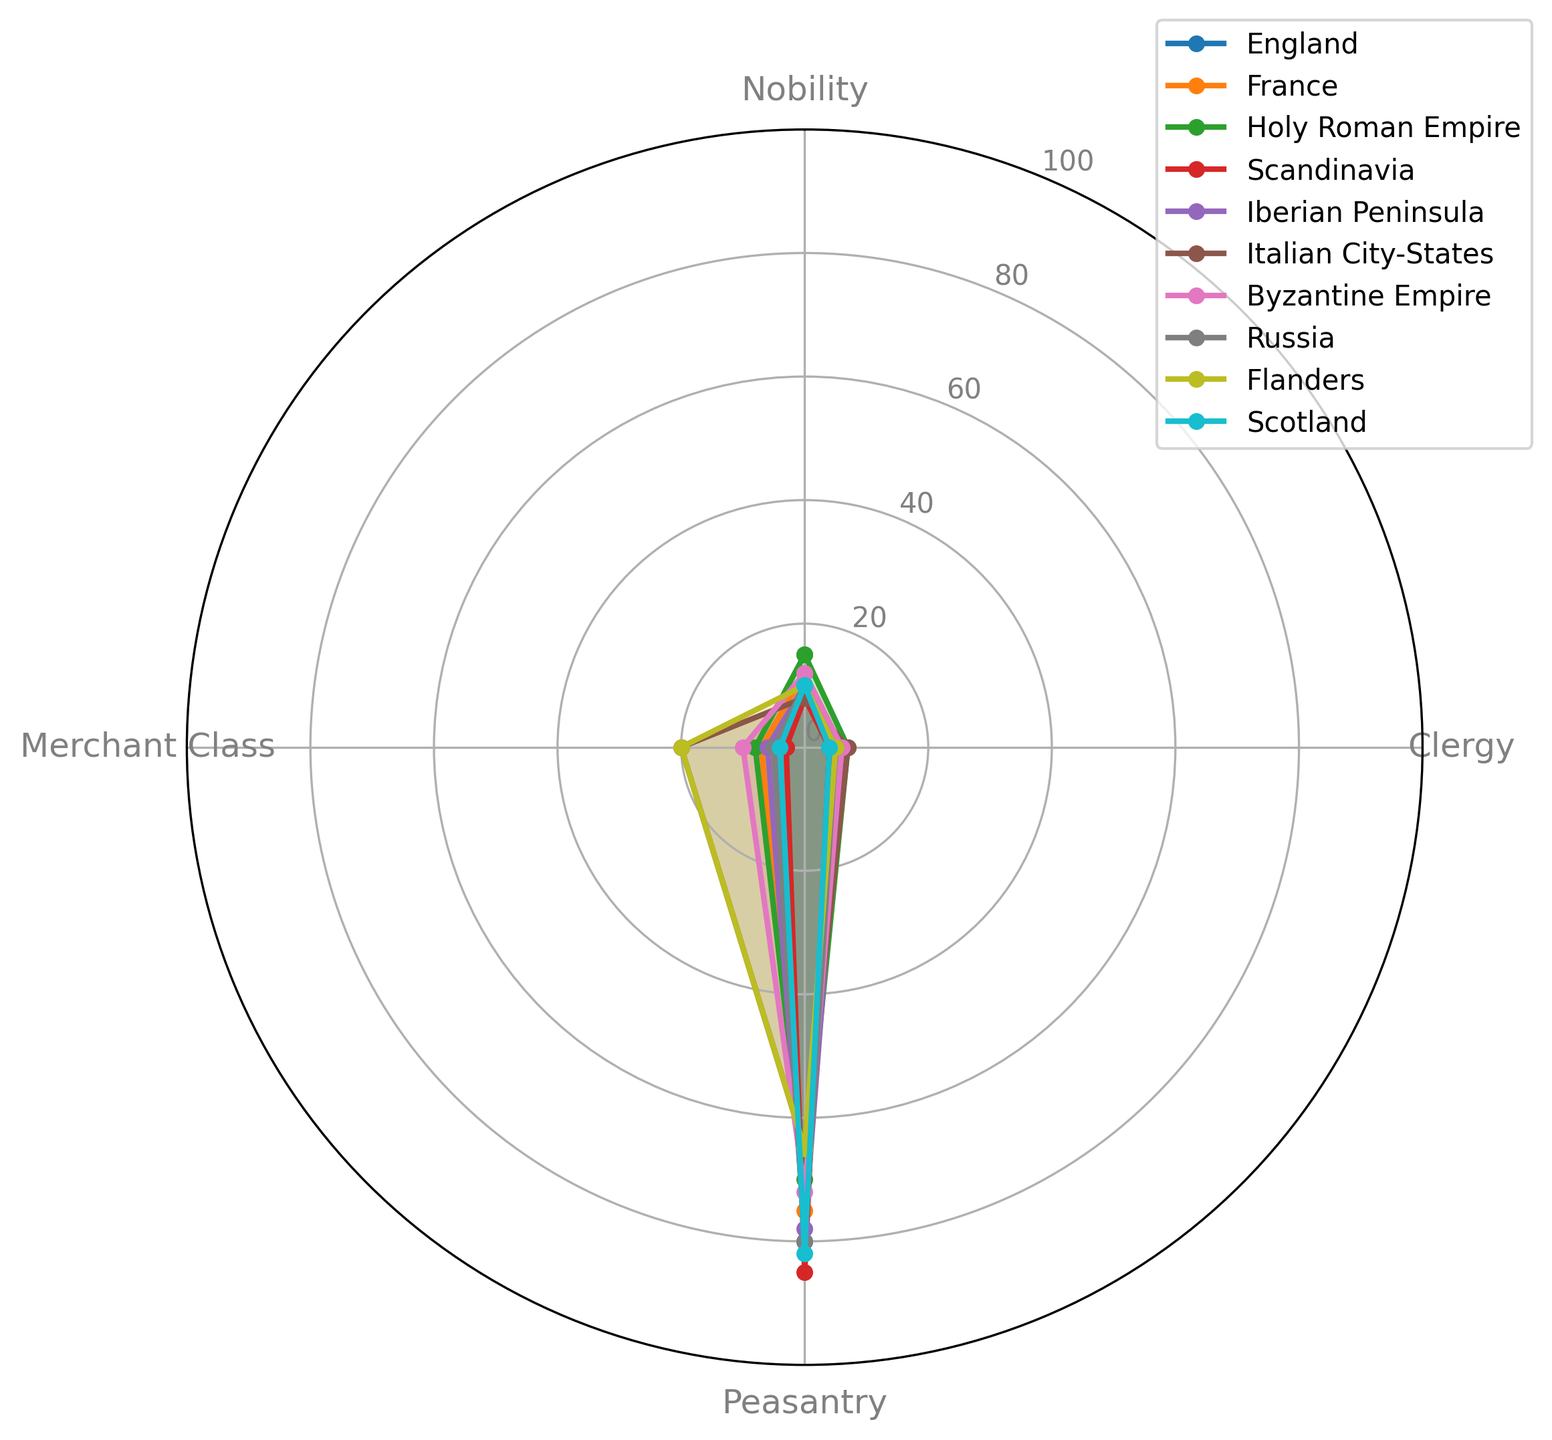Which region has the highest proportion of Nobility? Compare the Nobility values for each region. The highest proportion of Nobility is in the Holy Roman Empire with 15%.
Answer: Holy Roman Empire Which region has the smallest proportion of the Merchant Class? Look for the smallest value in the Merchant Class column. Scandinavia has the smallest proportion, which is 3%.
Answer: Scandinavia How does the proportion of Peasantry in France compare to that in Scotland? Compare the Peasantry proportions for France (75%) and Scotland (82%). Scotland has a higher proportion of Peasantry.
Answer: Scotland has a higher proportion of Peasantry Which two regions have an equal proportion of Clergy and what is that proportion? Look for regions with the same Clergy value. England and Russia both have 5%.
Answer: England and Russia, 5% Calculate the average proportion of the Merchant Class across all regions. Sum the Merchant Class values (5+7+8+3+6+20+10+20+5+4) which equals 88, then divide by the total number of regions (10). The average is 88/10 = 8.8%.
Answer: 8.8% What is the difference in the proportion of Peasantry between the region with the highest and the lowest values? The highest Peasantry value is in Scandinavia (85%) and the lowest is in the Italian City-States and Flanders (both 65%). The difference is 85% - 65% = 20%.
Answer: 20% Which region has the most balanced composition among all four social classes? Check for the region with the closest values across categories. The Italian City-States have the most balanced composition since their proportions are 8%, 7%, 65%, and 20%.
Answer: Italian City-States Which region has a higher proportion of Clergy than Peasantry? Look for a region where the Clergy value is greater than the Peasantry value. No region has a higher proportion of Clergy than Peasantry.
Answer: None What is the total proportion of Nobility and Clergy in France? Add the Nobility and Clergy values for France. 12% (Nobility) + 6% (Clergy) = 18%.
Answer: 18% Among the Holy Roman Empire, Byzantine Empire, and Russia, which region has the highest proportion of the Merchant Class? Compare the Merchant Class values: Holy Roman Empire (8%), Byzantine Empire (10%), Russia (5%). The Byzantine Empire has the highest proportion.
Answer: Byzantine Empire 